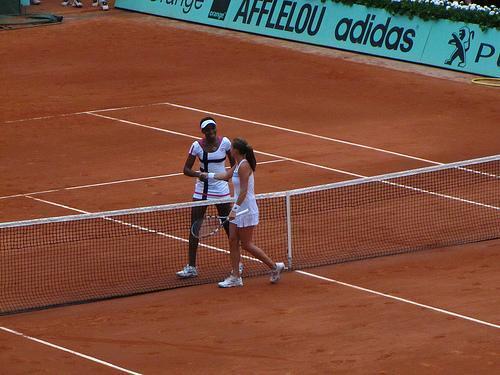How many players are on the court?
Give a very brief answer. 2. 